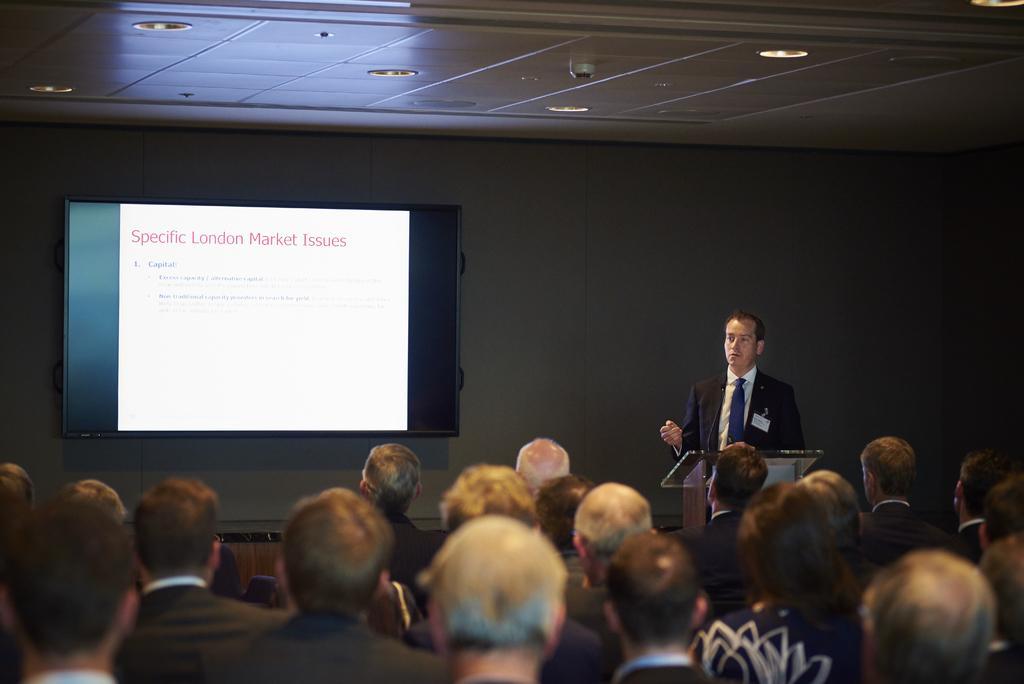Can you describe this image briefly? Group of people sitting and this man standing,in front of this person we can see podium. On the background we can see wall and screen. On top we can see lights. 